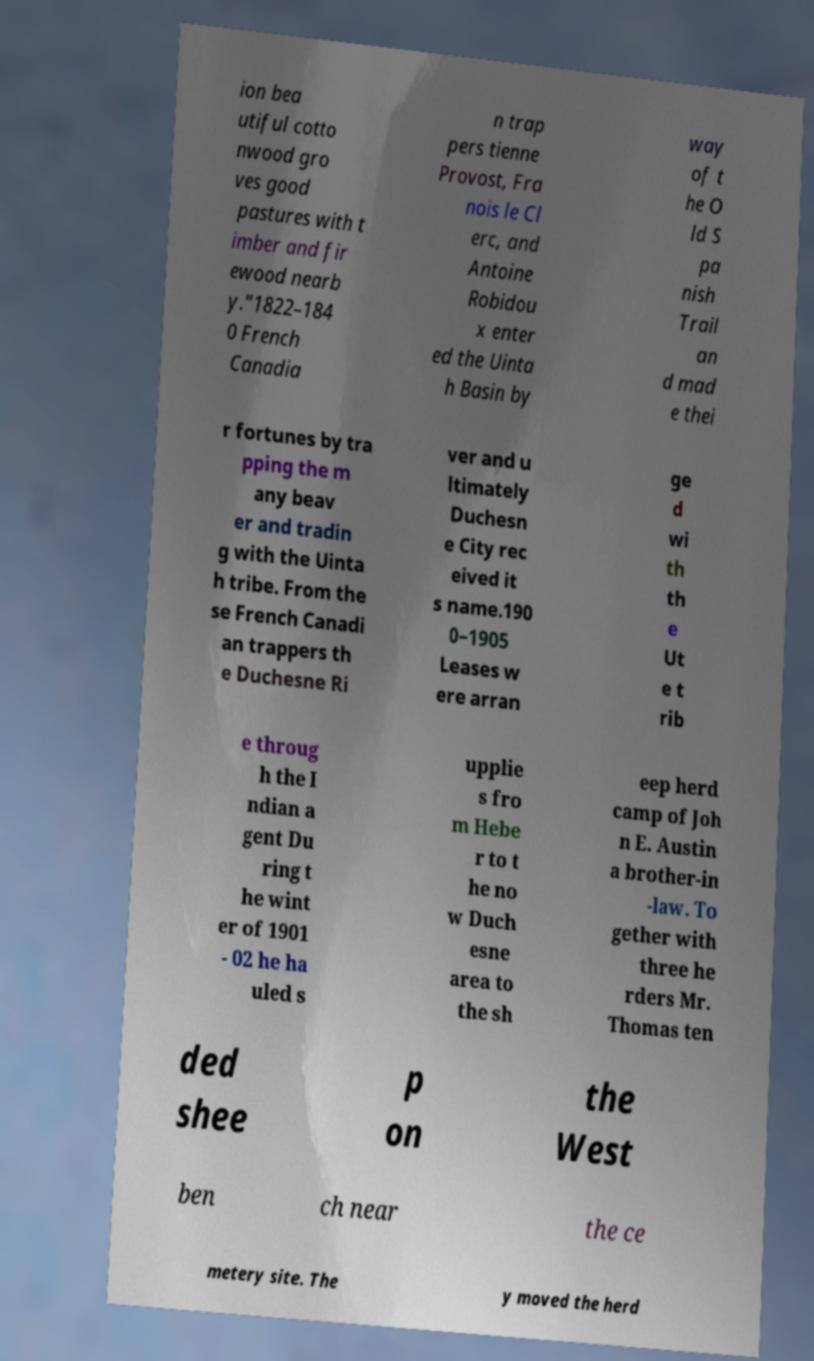There's text embedded in this image that I need extracted. Can you transcribe it verbatim? ion bea utiful cotto nwood gro ves good pastures with t imber and fir ewood nearb y."1822–184 0 French Canadia n trap pers tienne Provost, Fra nois le Cl erc, and Antoine Robidou x enter ed the Uinta h Basin by way of t he O ld S pa nish Trail an d mad e thei r fortunes by tra pping the m any beav er and tradin g with the Uinta h tribe. From the se French Canadi an trappers th e Duchesne Ri ver and u ltimately Duchesn e City rec eived it s name.190 0–1905 Leases w ere arran ge d wi th th e Ut e t rib e throug h the I ndian a gent Du ring t he wint er of 1901 - 02 he ha uled s upplie s fro m Hebe r to t he no w Duch esne area to the sh eep herd camp of Joh n E. Austin a brother-in -law. To gether with three he rders Mr. Thomas ten ded shee p on the West ben ch near the ce metery site. The y moved the herd 